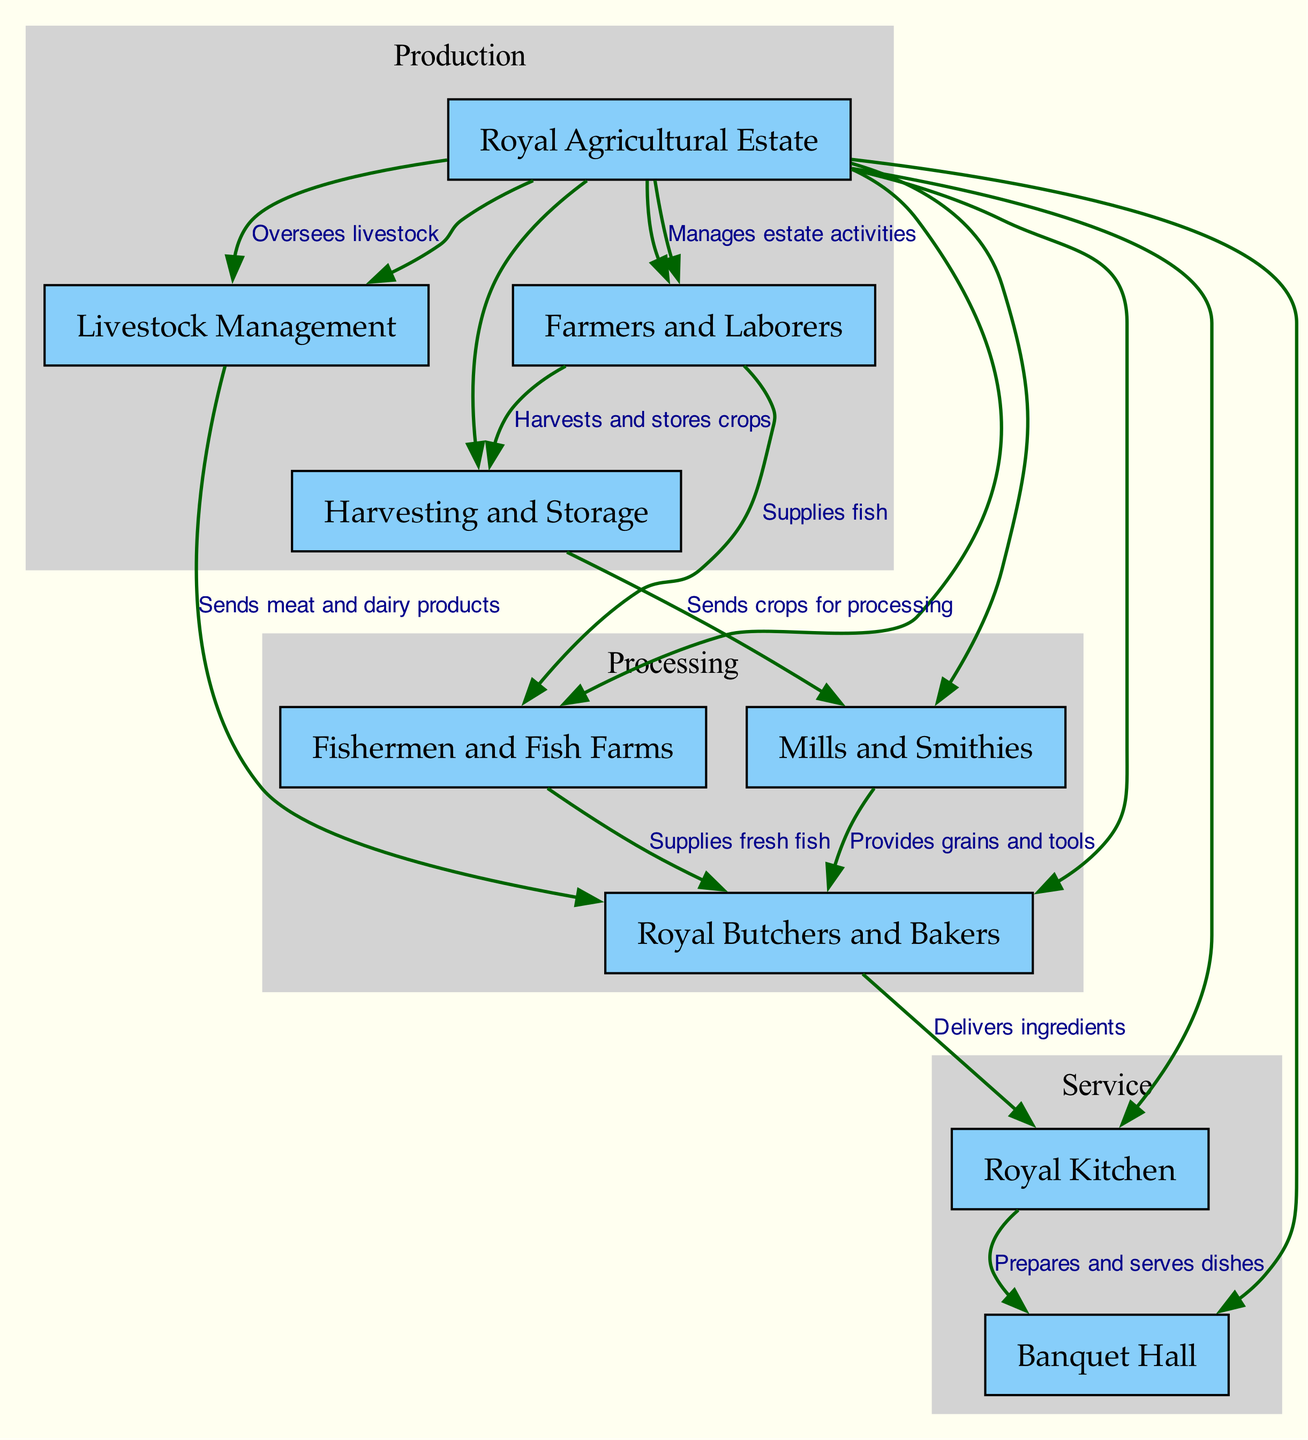What is the source of livestock management? The node labeled "Royal Agricultural Estate" is connected to "Livestock Management" through an edge labeled "Oversees livestock," indicating it is the source.
Answer: Royal Agricultural Estate How many nodes are in the diagram? The diagram contains ten nodes representing different stages of the culinary supply chain from the royal agricultural estate to the banquet hall.
Answer: 10 What do farmers and laborers supply to fish farms? According to the edge connecting "Farmers and Laborers" to "Fishermen and Fish Farms," labeled "Supplies fish," farmers and laborers provide a source of fish.
Answer: Fish What is delivered from the royal butchers and bakers to the royal kitchen? The edge labeled "Delivers ingredients" indicates that the royal butchers and bakers supply the royal kitchen with various ingredients necessary for cooking.
Answer: Ingredients Which node processes crops? The edge between "Harvesting and Storage" and "Mills and Smithies" indicates processing of crops, suggesting that "Mills and Smithies" is the node that processes them.
Answer: Mills and Smithies What label describes the relationship between the royal kitchen and the banquet hall? The relationship is indicated by the edge "Prepares and serves dishes," illustrating how the royal kitchen's function directly leads to the banquet hall's purpose.
Answer: Prepares and serves dishes Which node receives meat and dairy products? The edge labeled "Sends meat and dairy products" connects "Livestock Management" to "Royal Butchers and Bakers," showing that the royal butchers and bakers receive meat and dairy products.
Answer: Royal Butchers and Bakers From which node are grains provided? The edge connecting "Mills and Smithies" to "Royal Butchers and Bakers," labeled "Provides grains and tools," indicates that the royal butchers and bakers receive grains from the mills.
Answer: Mills and Smithies Who manages the estate activities? The connection between "Royal Agricultural Estate" and "Farmers and Laborers," with the edge labeled "Manages estate activities," signifies that the royal agricultural estate oversees these activities.
Answer: Royal Agricultural Estate 